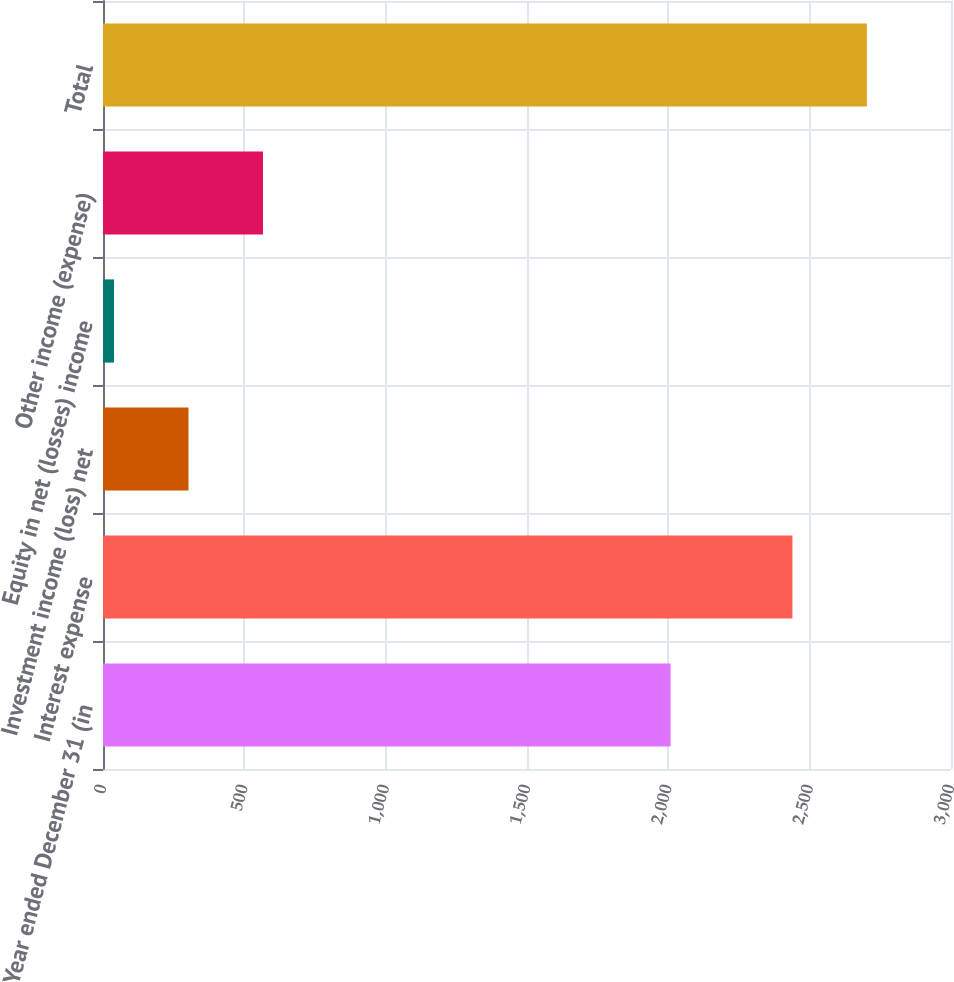<chart> <loc_0><loc_0><loc_500><loc_500><bar_chart><fcel>Year ended December 31 (in<fcel>Interest expense<fcel>Investment income (loss) net<fcel>Equity in net (losses) income<fcel>Other income (expense)<fcel>Total<nl><fcel>2008<fcel>2439<fcel>302.5<fcel>39<fcel>566<fcel>2702.5<nl></chart> 